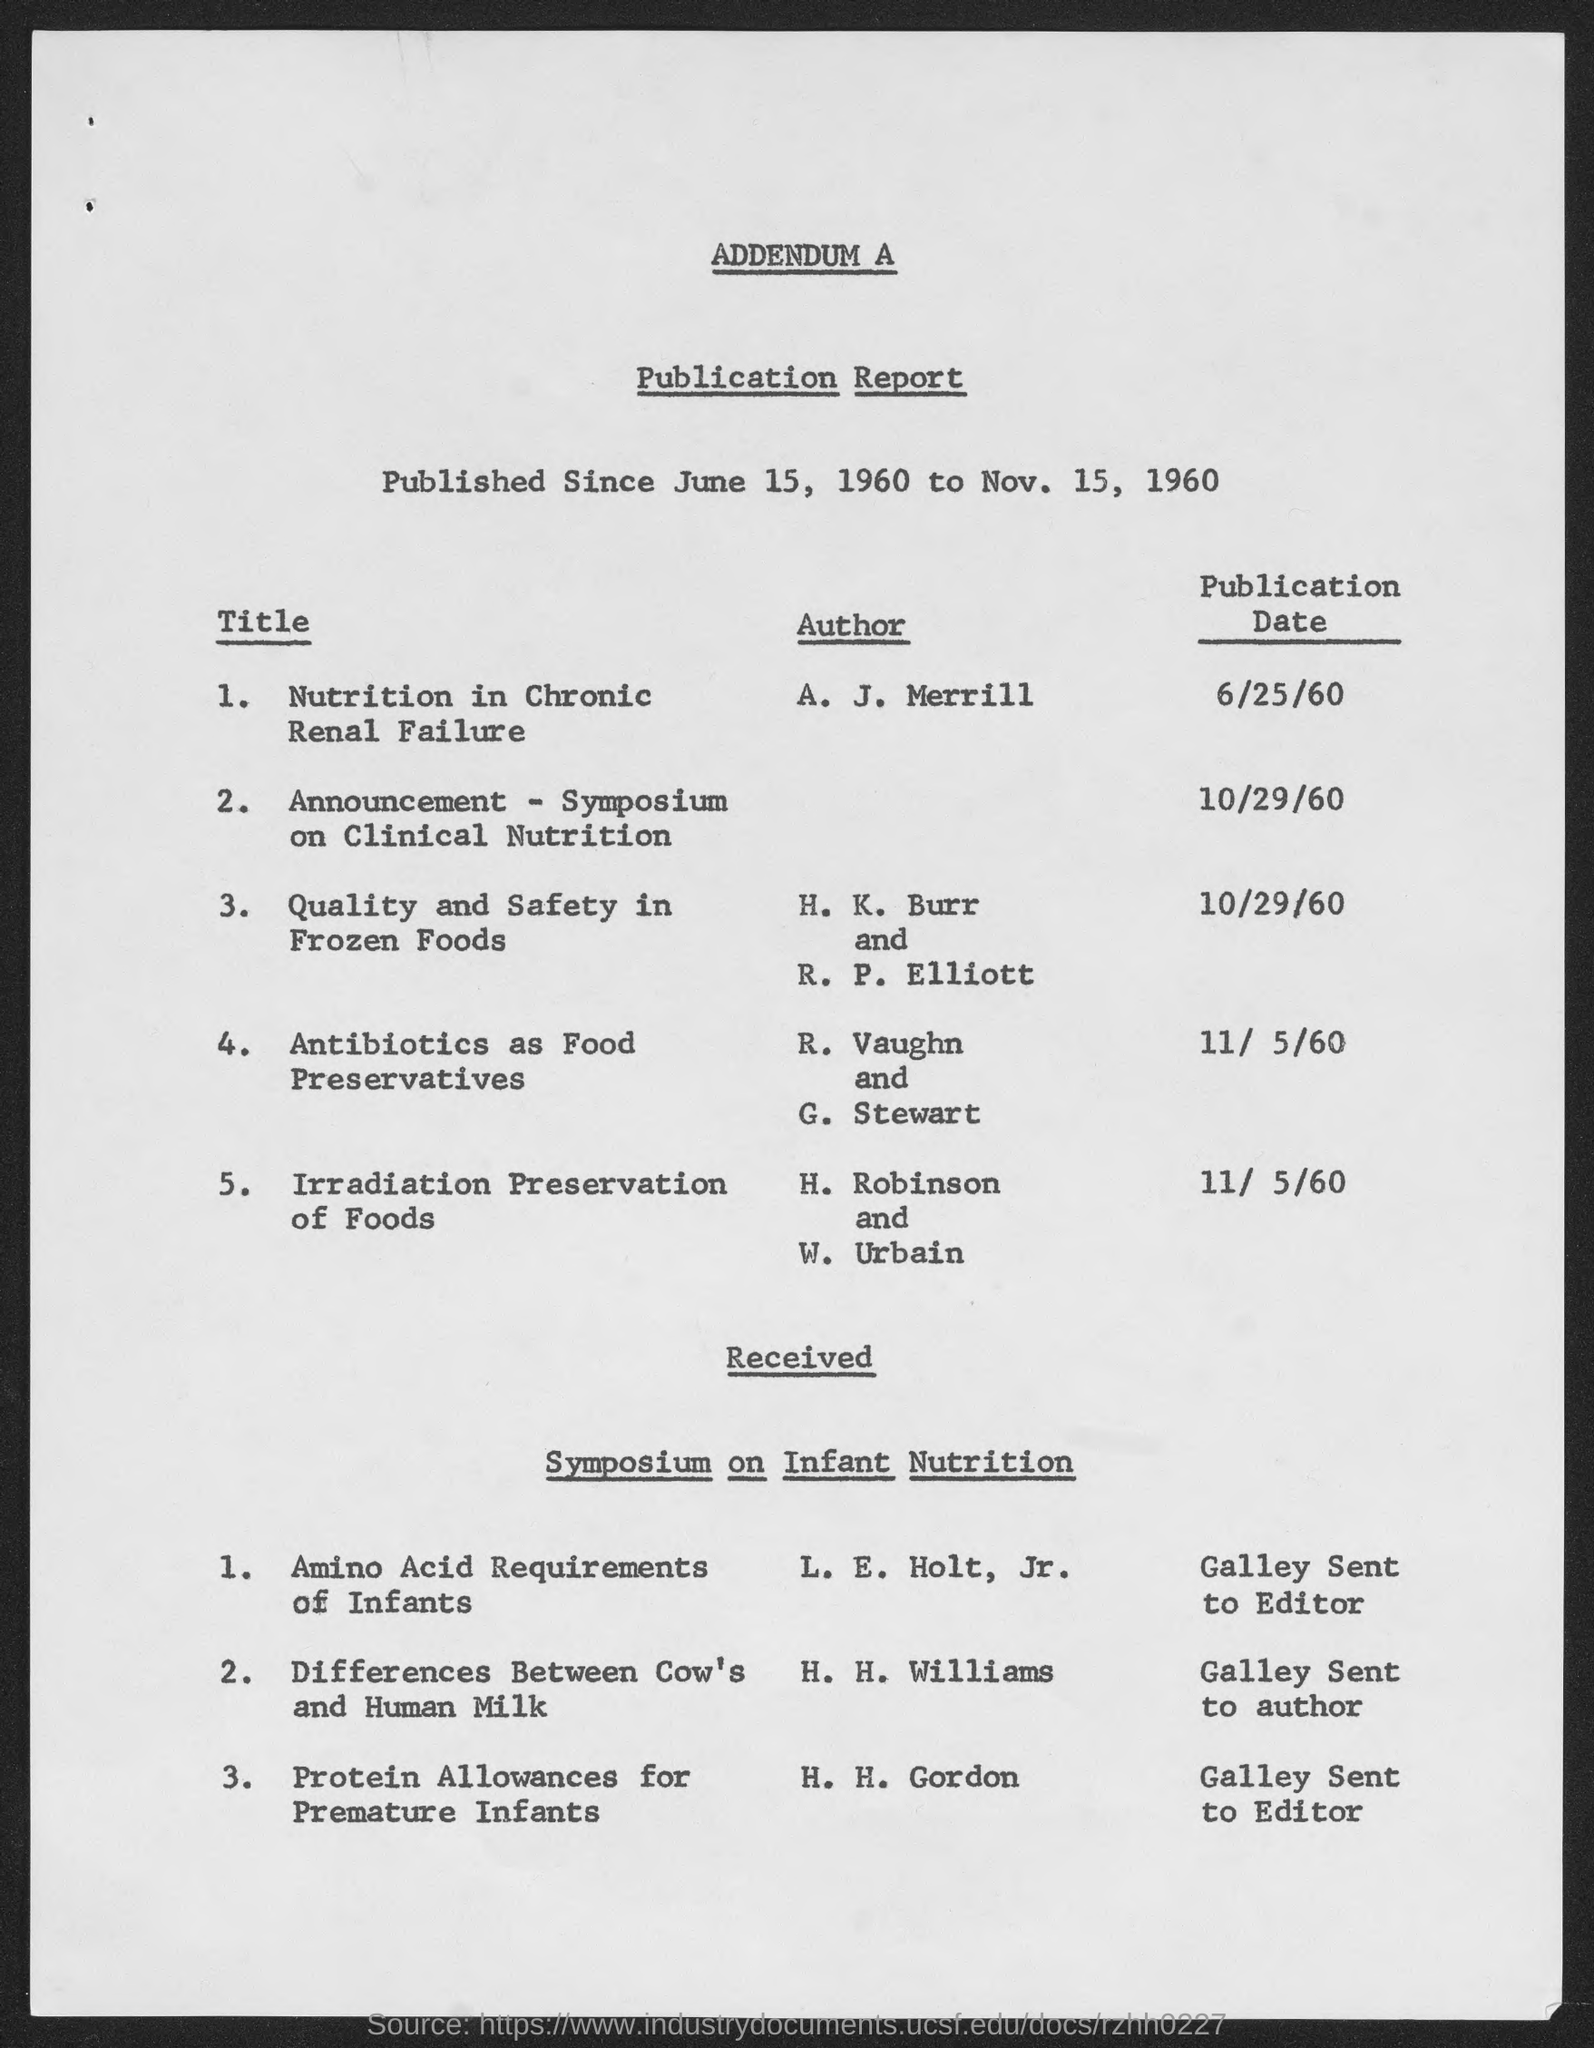Point out several critical features in this image. The author of "Nutrition in Chronic Renal Failure" is A. J. Merrill. The publication of "Quality and Safety in Frozen Foods" took place on October 29, 1960. 